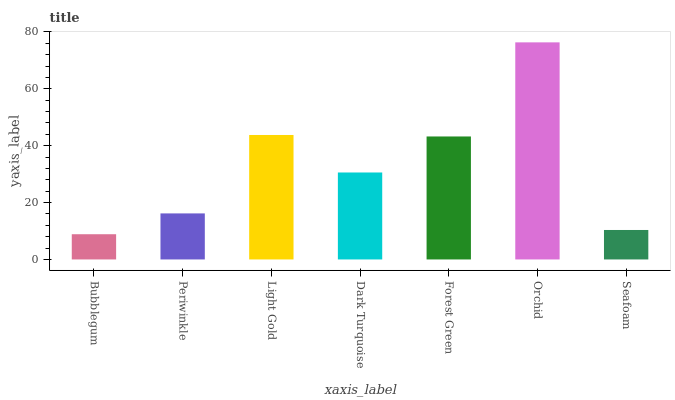Is Bubblegum the minimum?
Answer yes or no. Yes. Is Orchid the maximum?
Answer yes or no. Yes. Is Periwinkle the minimum?
Answer yes or no. No. Is Periwinkle the maximum?
Answer yes or no. No. Is Periwinkle greater than Bubblegum?
Answer yes or no. Yes. Is Bubblegum less than Periwinkle?
Answer yes or no. Yes. Is Bubblegum greater than Periwinkle?
Answer yes or no. No. Is Periwinkle less than Bubblegum?
Answer yes or no. No. Is Dark Turquoise the high median?
Answer yes or no. Yes. Is Dark Turquoise the low median?
Answer yes or no. Yes. Is Light Gold the high median?
Answer yes or no. No. Is Periwinkle the low median?
Answer yes or no. No. 